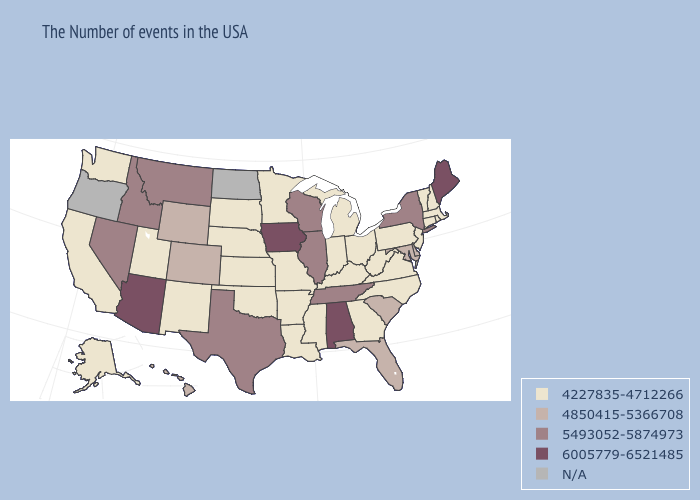What is the highest value in the MidWest ?
Short answer required. 6005779-6521485. What is the value of Florida?
Short answer required. 4850415-5366708. Among the states that border Michigan , does Wisconsin have the lowest value?
Quick response, please. No. Does Alaska have the lowest value in the USA?
Answer briefly. Yes. What is the lowest value in the USA?
Short answer required. 4227835-4712266. Among the states that border New York , which have the highest value?
Write a very short answer. Massachusetts, Vermont, Connecticut, New Jersey, Pennsylvania. What is the highest value in states that border Louisiana?
Answer briefly. 5493052-5874973. What is the lowest value in states that border Oklahoma?
Keep it brief. 4227835-4712266. What is the highest value in the USA?
Write a very short answer. 6005779-6521485. What is the highest value in the MidWest ?
Quick response, please. 6005779-6521485. Which states have the lowest value in the USA?
Concise answer only. Massachusetts, Rhode Island, New Hampshire, Vermont, Connecticut, New Jersey, Pennsylvania, Virginia, North Carolina, West Virginia, Ohio, Georgia, Michigan, Kentucky, Indiana, Mississippi, Louisiana, Missouri, Arkansas, Minnesota, Kansas, Nebraska, Oklahoma, South Dakota, New Mexico, Utah, California, Washington, Alaska. What is the highest value in the USA?
Write a very short answer. 6005779-6521485. Among the states that border Oregon , which have the lowest value?
Quick response, please. California, Washington. Name the states that have a value in the range 4850415-5366708?
Quick response, please. Delaware, Maryland, South Carolina, Florida, Wyoming, Colorado, Hawaii. 